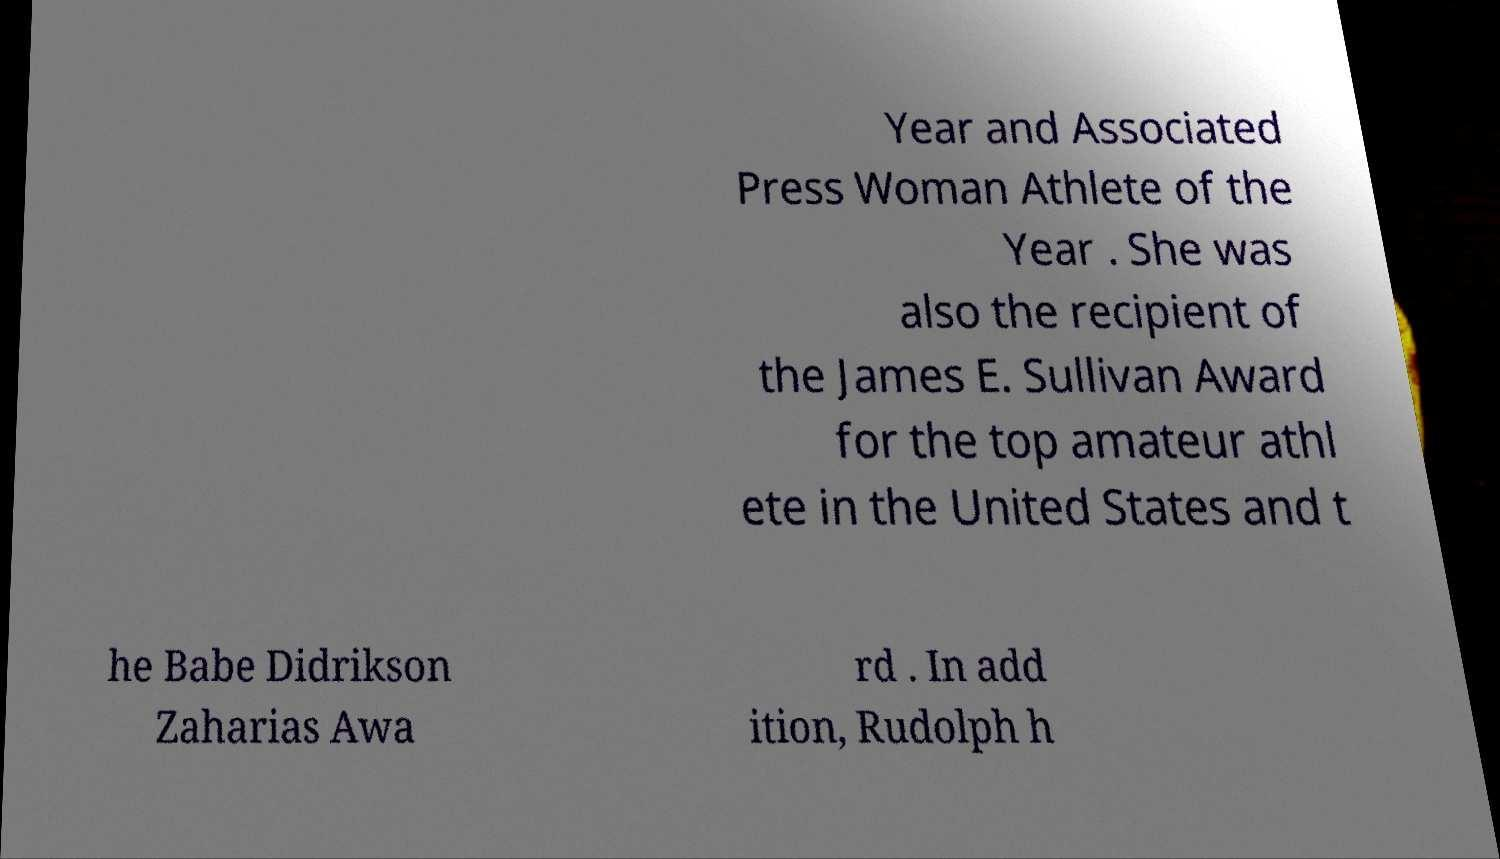Can you read and provide the text displayed in the image?This photo seems to have some interesting text. Can you extract and type it out for me? Year and Associated Press Woman Athlete of the Year . She was also the recipient of the James E. Sullivan Award for the top amateur athl ete in the United States and t he Babe Didrikson Zaharias Awa rd . In add ition, Rudolph h 